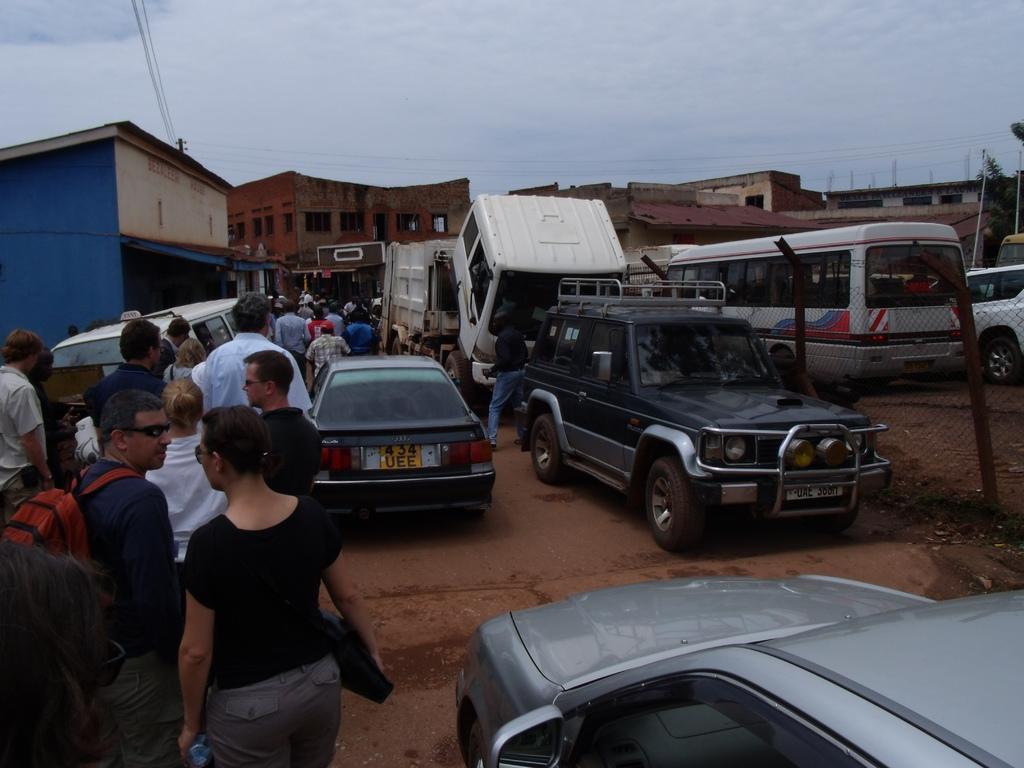Could you give a brief overview of what you see in this image? There are buildings, vehicles and a group of people present at the bottom of this image and the sky is in the background. 